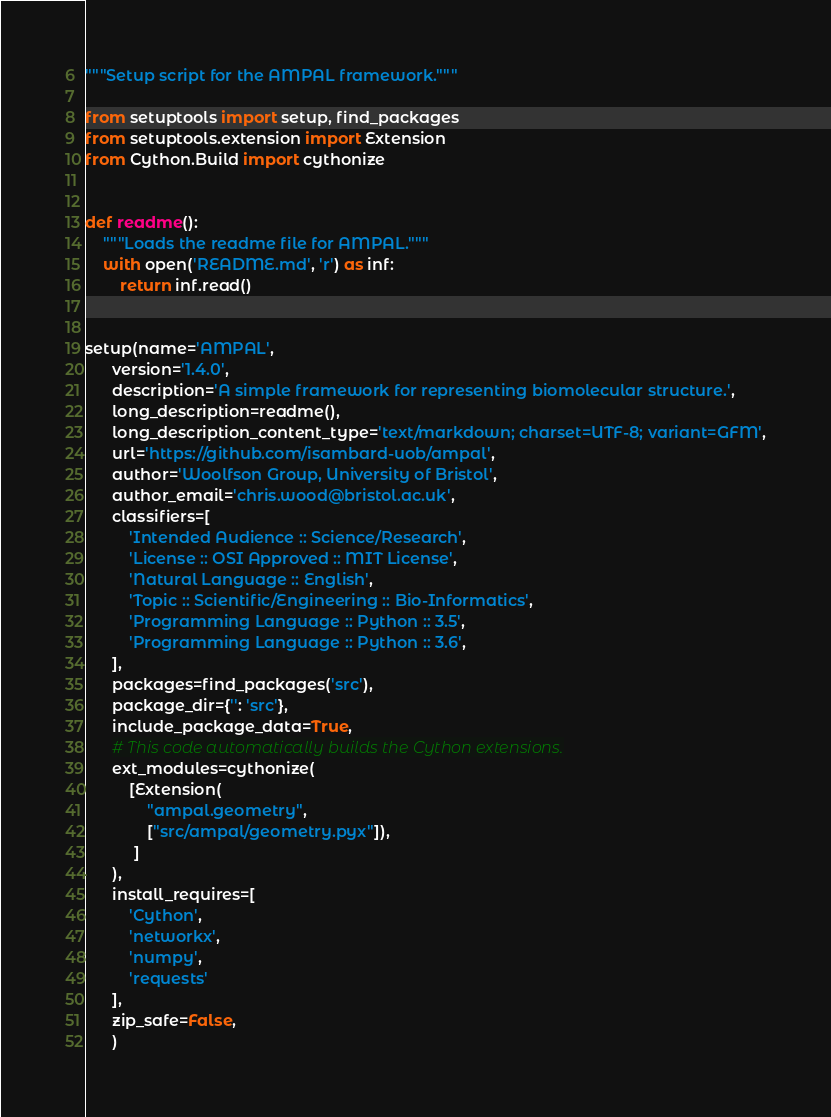Convert code to text. <code><loc_0><loc_0><loc_500><loc_500><_Python_>"""Setup script for the AMPAL framework."""

from setuptools import setup, find_packages
from setuptools.extension import Extension
from Cython.Build import cythonize


def readme():
    """Loads the readme file for AMPAL."""
    with open('README.md', 'r') as inf:
        return inf.read()


setup(name='AMPAL',
      version='1.4.0',
      description='A simple framework for representing biomolecular structure.',
      long_description=readme(),
      long_description_content_type='text/markdown; charset=UTF-8; variant=GFM',
      url='https://github.com/isambard-uob/ampal',
      author='Woolfson Group, University of Bristol',
      author_email='chris.wood@bristol.ac.uk',
      classifiers=[
          'Intended Audience :: Science/Research',
          'License :: OSI Approved :: MIT License',
          'Natural Language :: English',
          'Topic :: Scientific/Engineering :: Bio-Informatics',
          'Programming Language :: Python :: 3.5',
          'Programming Language :: Python :: 3.6',
      ],
      packages=find_packages('src'),
      package_dir={'': 'src'},
      include_package_data=True,
      # This code automatically builds the Cython extensions.
      ext_modules=cythonize(
          [Extension(
              "ampal.geometry",
              ["src/ampal/geometry.pyx"]),
           ]
      ),
      install_requires=[
          'Cython',
          'networkx',
          'numpy',
          'requests'
      ],
      zip_safe=False,
      )
</code> 